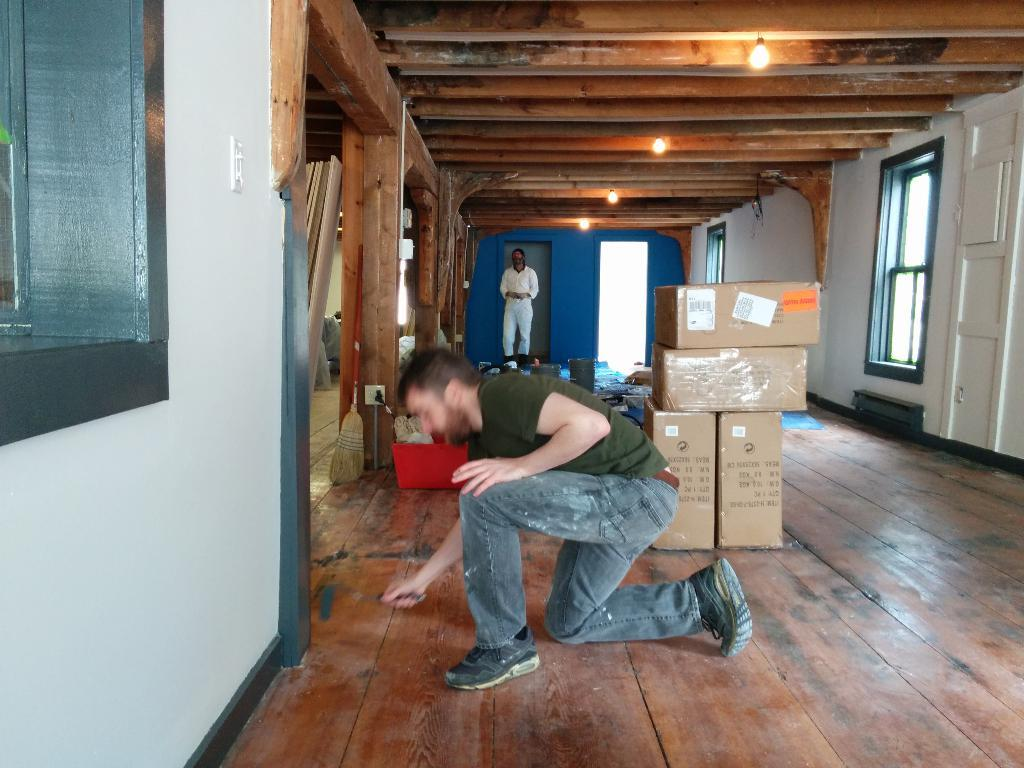Who or what can be seen in the image? There are people in the image. What is on the floor in the image? There are boxes and other objects on the floor. Where is the window located in the image? The window is at the left side of the image. What can be seen in the image that provides light? There are lights in the image. What type of planes are flying in the image? There are no planes visible in the image. 